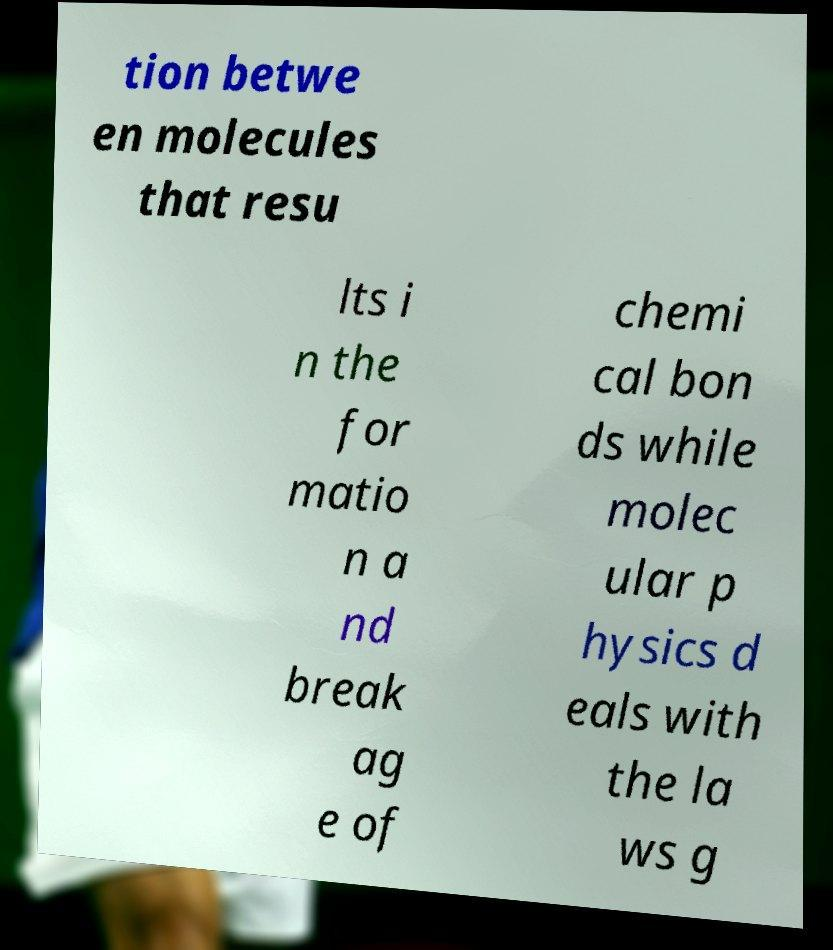For documentation purposes, I need the text within this image transcribed. Could you provide that? tion betwe en molecules that resu lts i n the for matio n a nd break ag e of chemi cal bon ds while molec ular p hysics d eals with the la ws g 